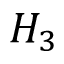Convert formula to latex. <formula><loc_0><loc_0><loc_500><loc_500>H _ { 3 }</formula> 